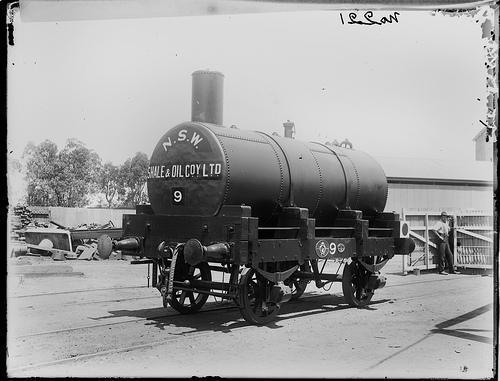How many cats are there?
Give a very brief answer. 0. 